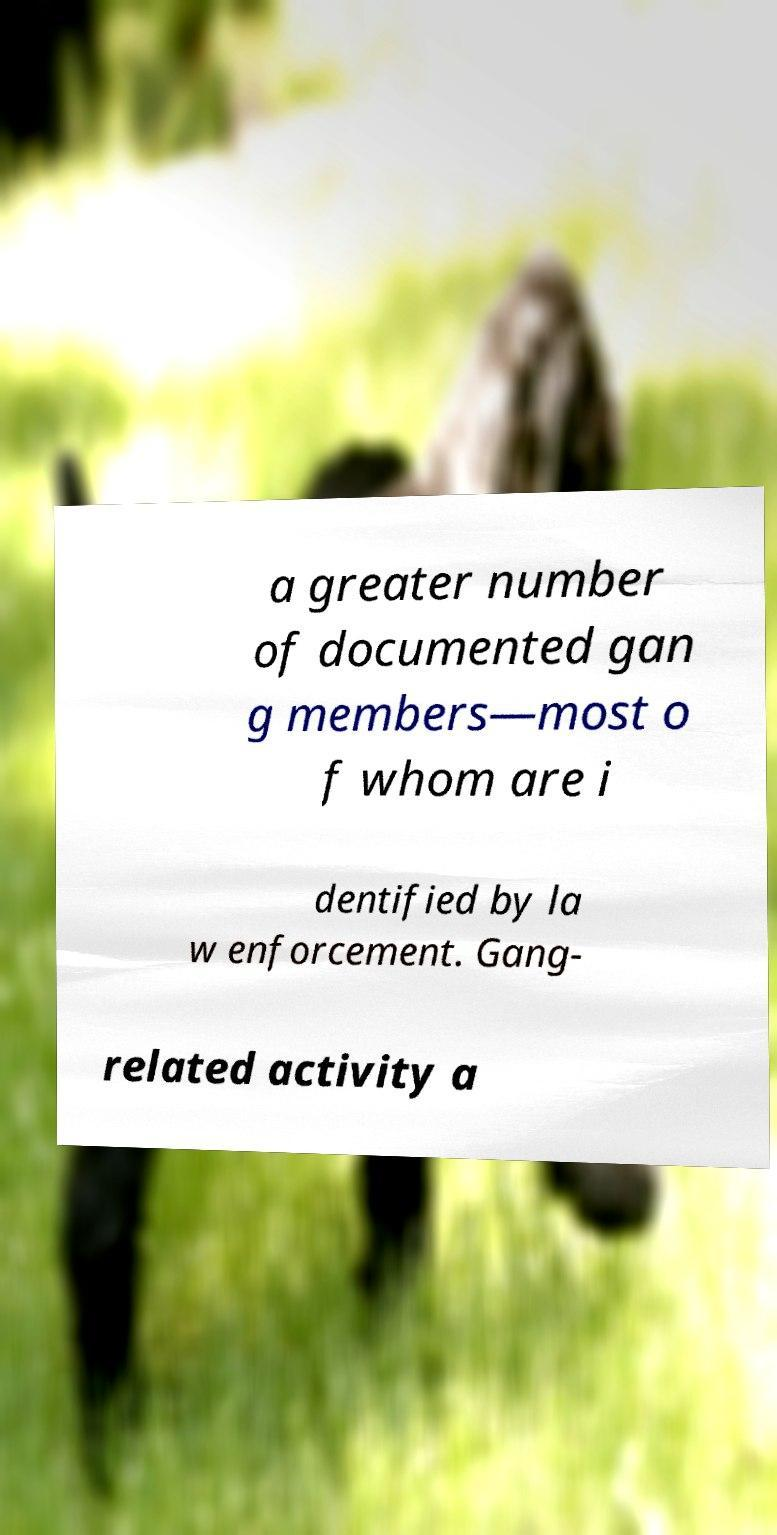I need the written content from this picture converted into text. Can you do that? a greater number of documented gan g members—most o f whom are i dentified by la w enforcement. Gang- related activity a 